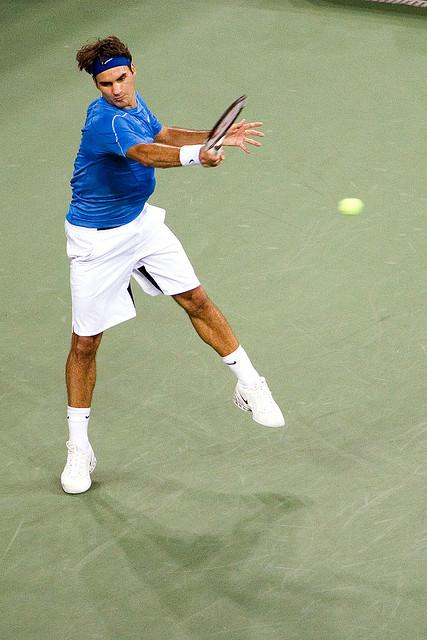What did this tennis player just do? Please explain your reasoning. returned ball. The players is hitting the green ball back. 